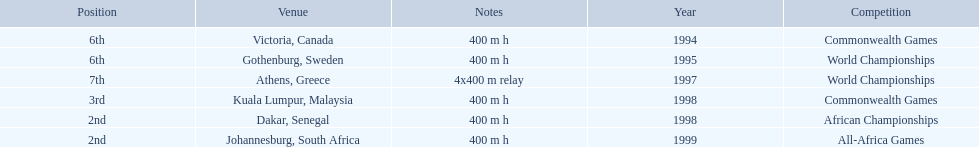Which year had the most competitions? 1998. 